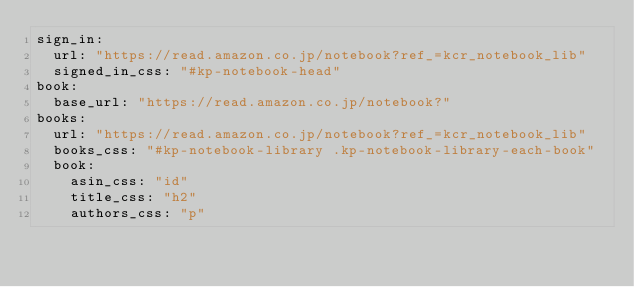Convert code to text. <code><loc_0><loc_0><loc_500><loc_500><_YAML_>sign_in:
  url: "https://read.amazon.co.jp/notebook?ref_=kcr_notebook_lib"
  signed_in_css: "#kp-notebook-head"
book:
  base_url: "https://read.amazon.co.jp/notebook?"
books:
  url: "https://read.amazon.co.jp/notebook?ref_=kcr_notebook_lib"
  books_css: "#kp-notebook-library .kp-notebook-library-each-book"
  book:
    asin_css: "id"
    title_css: "h2"
    authors_css: "p"
</code> 